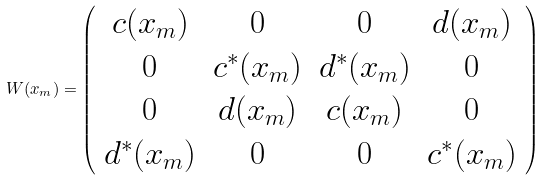<formula> <loc_0><loc_0><loc_500><loc_500>W ( x _ { m } ) = \left ( \begin{array} { c c c c } c ( x _ { m } ) & 0 & 0 & d ( x _ { m } ) \\ 0 & c ^ { * } ( x _ { m } ) & d ^ { * } ( x _ { m } ) & 0 \\ 0 & d ( x _ { m } ) & c ( x _ { m } ) & 0 \\ d ^ { * } ( x _ { m } ) & 0 & 0 & c ^ { * } ( x _ { m } ) \end{array} \right )</formula> 